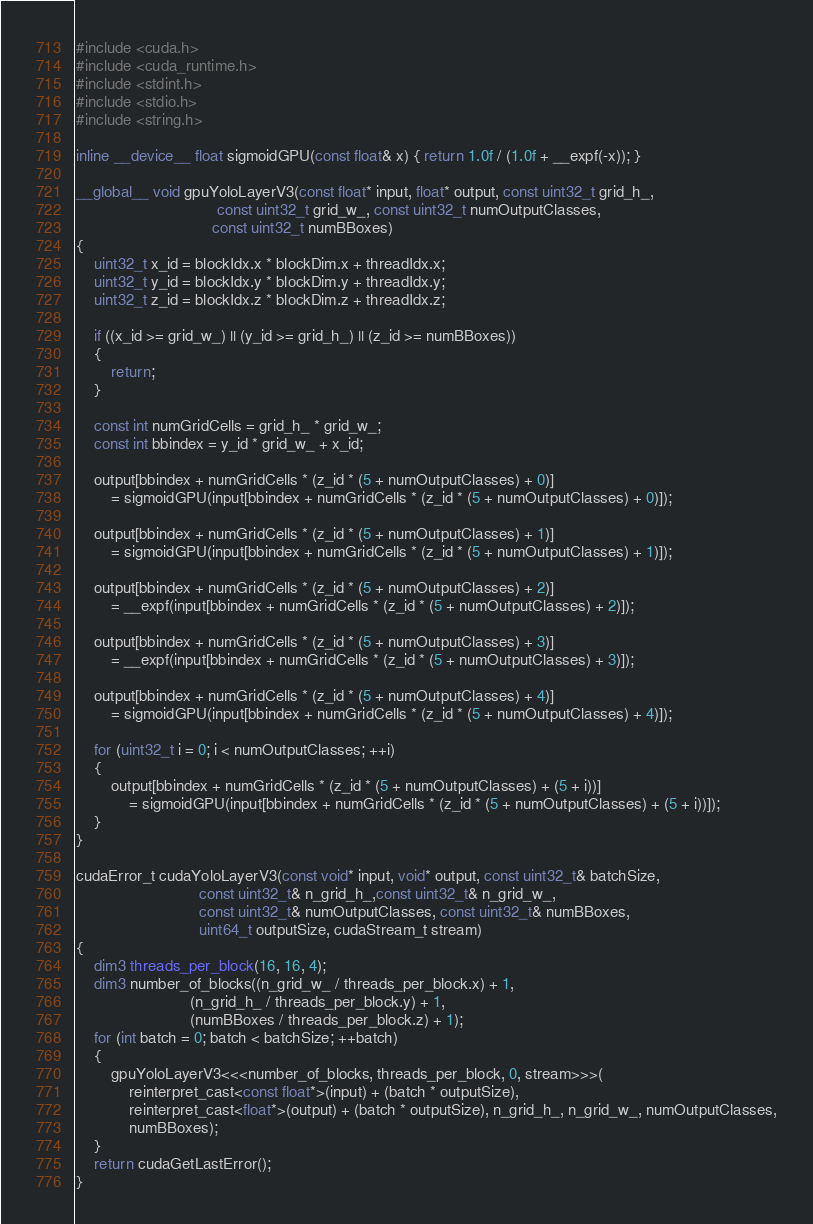<code> <loc_0><loc_0><loc_500><loc_500><_Cuda_>
#include <cuda.h>
#include <cuda_runtime.h>
#include <stdint.h>
#include <stdio.h>
#include <string.h>

inline __device__ float sigmoidGPU(const float& x) { return 1.0f / (1.0f + __expf(-x)); }

__global__ void gpuYoloLayerV3(const float* input, float* output, const uint32_t grid_h_,
								const uint32_t grid_w_, const uint32_t numOutputClasses,
                               const uint32_t numBBoxes)
{
    uint32_t x_id = blockIdx.x * blockDim.x + threadIdx.x;
    uint32_t y_id = blockIdx.y * blockDim.y + threadIdx.y;
    uint32_t z_id = blockIdx.z * blockDim.z + threadIdx.z;

    if ((x_id >= grid_w_) || (y_id >= grid_h_) || (z_id >= numBBoxes))
    {
        return;
    }

    const int numGridCells = grid_h_ * grid_w_;
    const int bbindex = y_id * grid_w_ + x_id;

    output[bbindex + numGridCells * (z_id * (5 + numOutputClasses) + 0)]
        = sigmoidGPU(input[bbindex + numGridCells * (z_id * (5 + numOutputClasses) + 0)]);

    output[bbindex + numGridCells * (z_id * (5 + numOutputClasses) + 1)]
        = sigmoidGPU(input[bbindex + numGridCells * (z_id * (5 + numOutputClasses) + 1)]);

    output[bbindex + numGridCells * (z_id * (5 + numOutputClasses) + 2)]
        = __expf(input[bbindex + numGridCells * (z_id * (5 + numOutputClasses) + 2)]);

    output[bbindex + numGridCells * (z_id * (5 + numOutputClasses) + 3)]
        = __expf(input[bbindex + numGridCells * (z_id * (5 + numOutputClasses) + 3)]);

    output[bbindex + numGridCells * (z_id * (5 + numOutputClasses) + 4)]
        = sigmoidGPU(input[bbindex + numGridCells * (z_id * (5 + numOutputClasses) + 4)]);

    for (uint32_t i = 0; i < numOutputClasses; ++i)
    {
        output[bbindex + numGridCells * (z_id * (5 + numOutputClasses) + (5 + i))]
            = sigmoidGPU(input[bbindex + numGridCells * (z_id * (5 + numOutputClasses) + (5 + i))]);
    }
}

cudaError_t cudaYoloLayerV3(const void* input, void* output, const uint32_t& batchSize, 
							const uint32_t& n_grid_h_,const uint32_t& n_grid_w_,
                            const uint32_t& numOutputClasses, const uint32_t& numBBoxes,
                            uint64_t outputSize, cudaStream_t stream)
{
    dim3 threads_per_block(16, 16, 4);
    dim3 number_of_blocks((n_grid_w_ / threads_per_block.x) + 1,
                          (n_grid_h_ / threads_per_block.y) + 1,
                          (numBBoxes / threads_per_block.z) + 1);
    for (int batch = 0; batch < batchSize; ++batch)
    {
        gpuYoloLayerV3<<<number_of_blocks, threads_per_block, 0, stream>>>(
            reinterpret_cast<const float*>(input) + (batch * outputSize),
            reinterpret_cast<float*>(output) + (batch * outputSize), n_grid_h_, n_grid_w_, numOutputClasses,
            numBBoxes);
    }
    return cudaGetLastError();
}</code> 